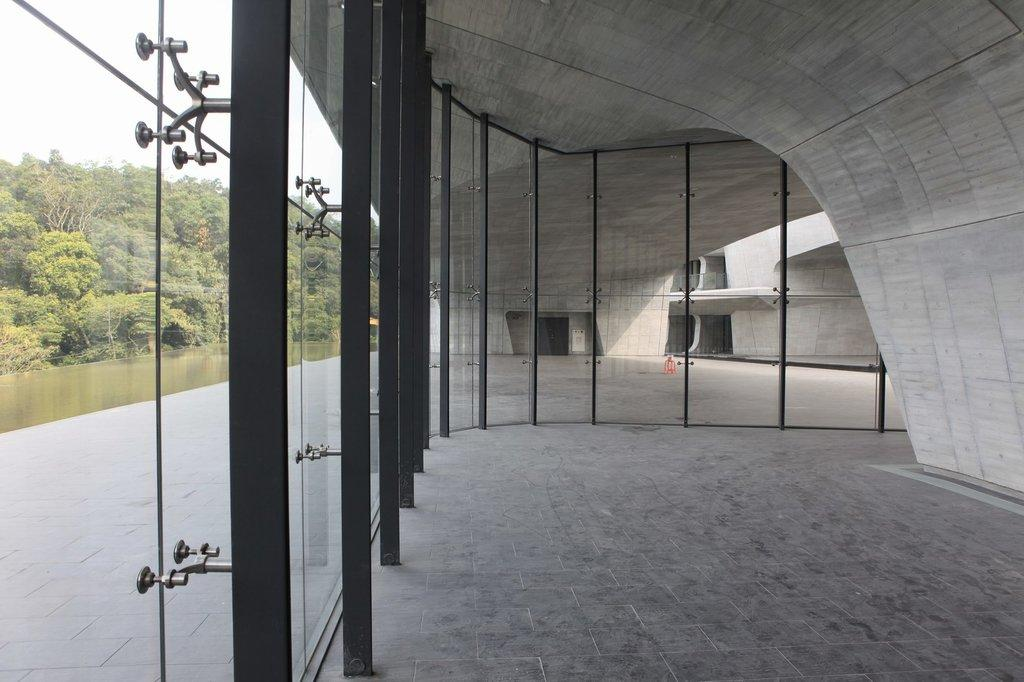What type of material is used for the windows in the image? The windows in the image are made of glass. What other structural elements can be seen in the image? There are metal poles and a wall visible in the image. What is located on the left side of the image? There is a group of trees on the left side of the image. What is visible in the image}? The sky is visible in the image. Can you tell me how many pieces of pie are on the wall in the image? There is no pie present in the image; it features glass windows, metal poles, a wall, a group of trees, and the sky. How many visitors are visible in the image? There are no visitors present in the image; it only shows glass windows, metal poles, a wall, a group of trees, and the sky. 